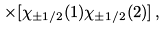Convert formula to latex. <formula><loc_0><loc_0><loc_500><loc_500>\times [ \chi _ { \pm 1 / 2 } ( 1 ) \chi _ { \pm 1 / 2 } ( 2 ) ] \, ,</formula> 